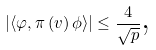Convert formula to latex. <formula><loc_0><loc_0><loc_500><loc_500>\left | \left \langle \varphi , \pi \left ( v \right ) \phi \right \rangle \right | \leq \frac { 4 } { \sqrt { p } } \text {,}</formula> 